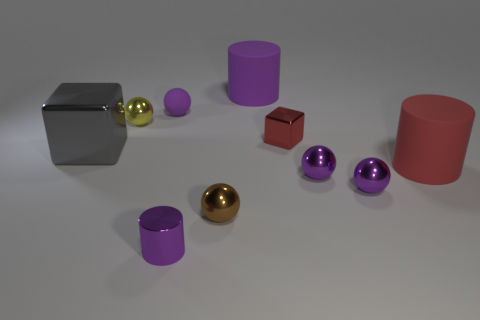There is a large cylinder that is on the right side of the red metallic block; what is its color?
Offer a terse response. Red. What material is the cylinder that is on the right side of the tiny shiny cube that is behind the gray metallic thing?
Give a very brief answer. Rubber. Are there any cubes that have the same size as the matte ball?
Your answer should be very brief. Yes. How many objects are metal spheres right of the large purple cylinder or metal objects left of the purple matte cylinder?
Keep it short and to the point. 6. Does the shiny block that is right of the purple shiny cylinder have the same size as the purple cylinder that is in front of the big purple cylinder?
Your answer should be compact. Yes. There is a large rubber object that is on the right side of the large purple rubber cylinder; is there a big gray shiny block that is on the right side of it?
Ensure brevity in your answer.  No. There is a brown metal sphere; how many small metal objects are to the right of it?
Offer a terse response. 3. How many other objects are the same color as the small cylinder?
Your answer should be very brief. 4. Are there fewer cylinders in front of the small matte object than big matte cylinders in front of the small red metallic object?
Give a very brief answer. No. What number of things are big things in front of the yellow sphere or large brown metallic cubes?
Provide a succinct answer. 2. 